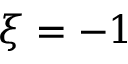<formula> <loc_0><loc_0><loc_500><loc_500>\xi = - 1</formula> 